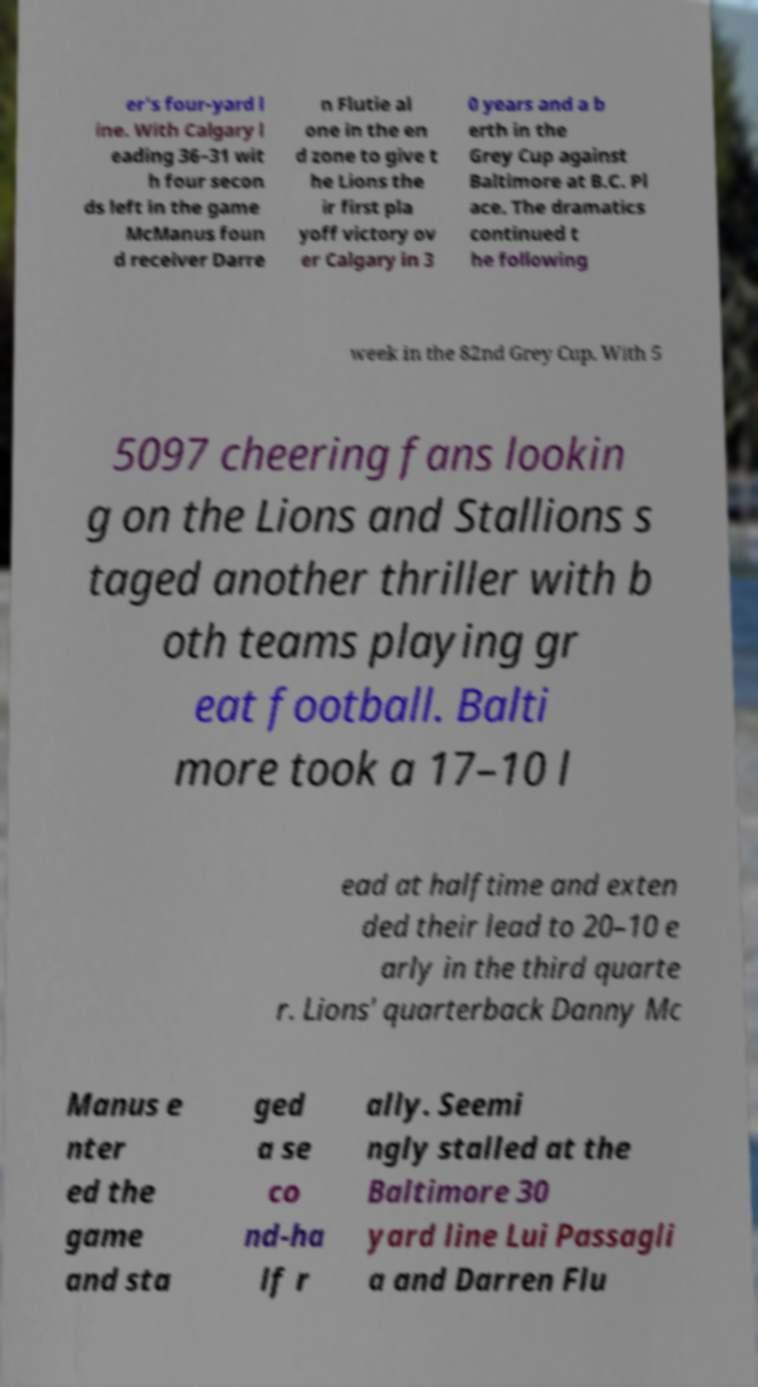For documentation purposes, I need the text within this image transcribed. Could you provide that? er's four-yard l ine. With Calgary l eading 36–31 wit h four secon ds left in the game McManus foun d receiver Darre n Flutie al one in the en d zone to give t he Lions the ir first pla yoff victory ov er Calgary in 3 0 years and a b erth in the Grey Cup against Baltimore at B.C. Pl ace. The dramatics continued t he following week in the 82nd Grey Cup. With 5 5097 cheering fans lookin g on the Lions and Stallions s taged another thriller with b oth teams playing gr eat football. Balti more took a 17–10 l ead at halftime and exten ded their lead to 20–10 e arly in the third quarte r. Lions' quarterback Danny Mc Manus e nter ed the game and sta ged a se co nd-ha lf r ally. Seemi ngly stalled at the Baltimore 30 yard line Lui Passagli a and Darren Flu 